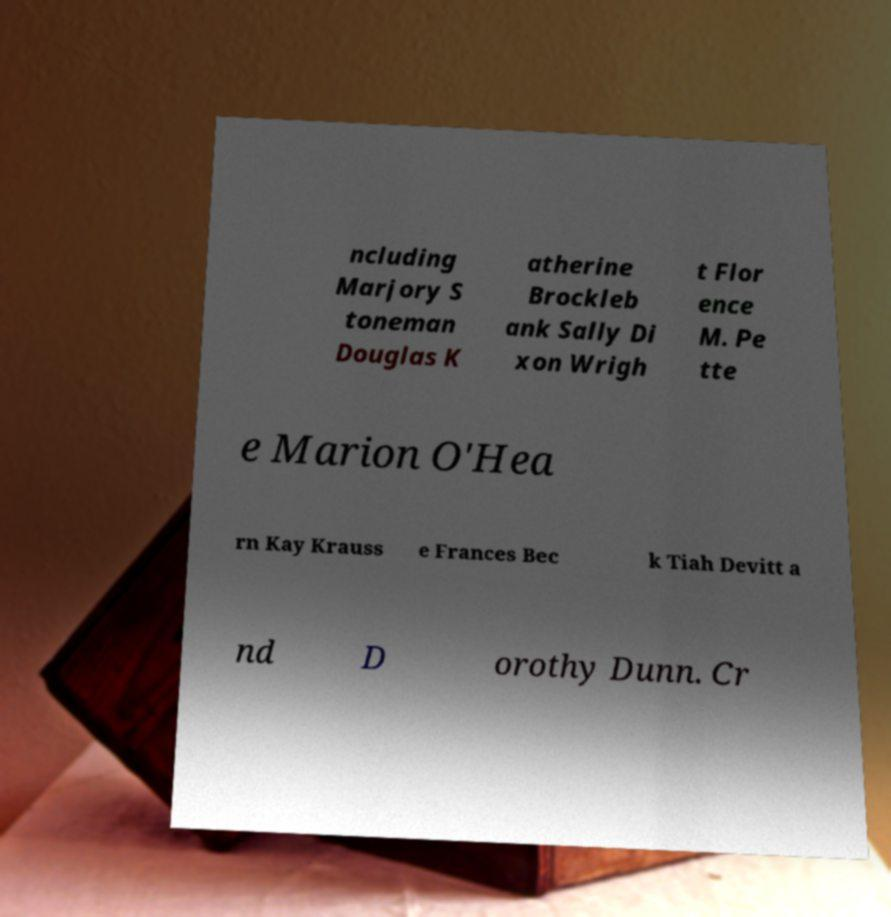There's text embedded in this image that I need extracted. Can you transcribe it verbatim? ncluding Marjory S toneman Douglas K atherine Brockleb ank Sally Di xon Wrigh t Flor ence M. Pe tte e Marion O'Hea rn Kay Krauss e Frances Bec k Tiah Devitt a nd D orothy Dunn. Cr 